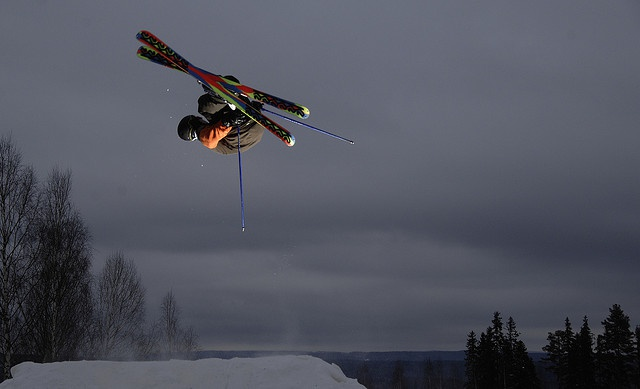Describe the objects in this image and their specific colors. I can see skis in gray, black, maroon, darkgreen, and navy tones and people in gray, black, and maroon tones in this image. 